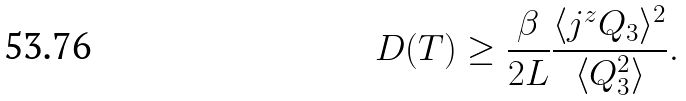<formula> <loc_0><loc_0><loc_500><loc_500>D ( T ) \geq \frac { \beta } { 2 L } \frac { \langle j ^ { z } Q _ { 3 } \rangle ^ { 2 } } { \langle Q _ { 3 } ^ { 2 } \rangle } .</formula> 